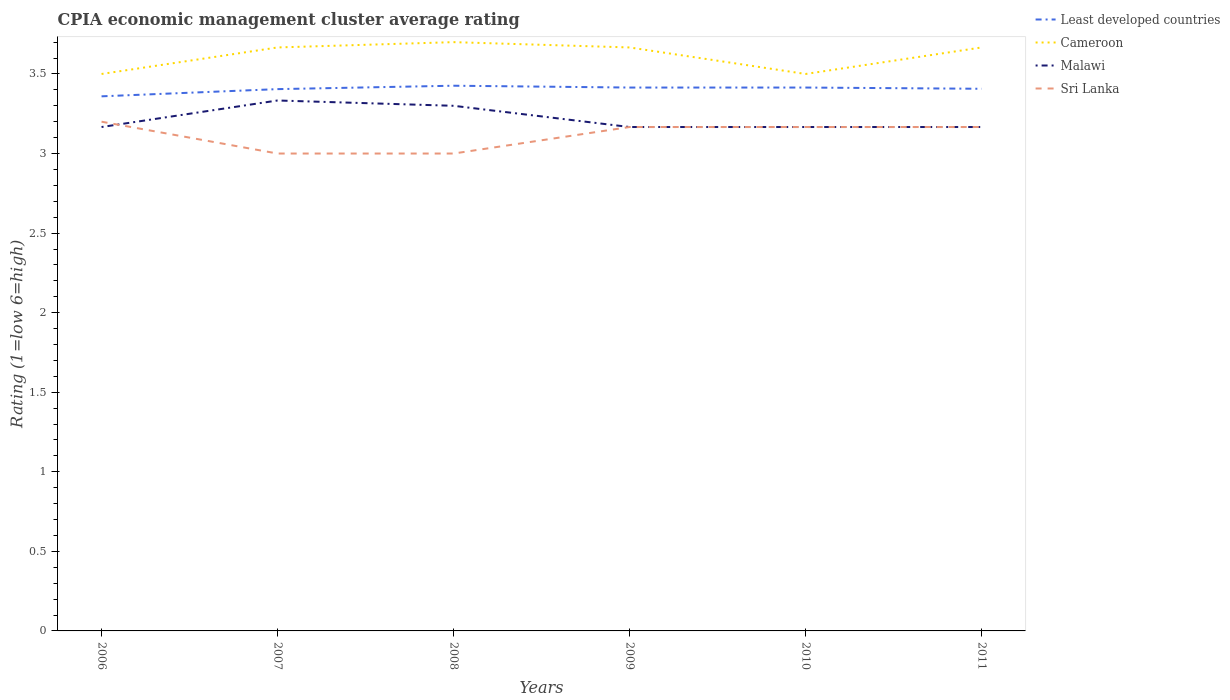How many different coloured lines are there?
Your answer should be very brief. 4. Does the line corresponding to Cameroon intersect with the line corresponding to Sri Lanka?
Make the answer very short. No. Across all years, what is the maximum CPIA rating in Sri Lanka?
Make the answer very short. 3. In which year was the CPIA rating in Malawi maximum?
Make the answer very short. 2006. What is the total CPIA rating in Sri Lanka in the graph?
Offer a terse response. -0.17. What is the difference between the highest and the second highest CPIA rating in Least developed countries?
Provide a succinct answer. 0.07. What is the difference between the highest and the lowest CPIA rating in Cameroon?
Keep it short and to the point. 4. Is the CPIA rating in Least developed countries strictly greater than the CPIA rating in Malawi over the years?
Your answer should be compact. No. How many lines are there?
Ensure brevity in your answer.  4. How many years are there in the graph?
Give a very brief answer. 6. What is the difference between two consecutive major ticks on the Y-axis?
Your response must be concise. 0.5. How many legend labels are there?
Provide a succinct answer. 4. How are the legend labels stacked?
Your response must be concise. Vertical. What is the title of the graph?
Ensure brevity in your answer.  CPIA economic management cluster average rating. What is the label or title of the X-axis?
Provide a succinct answer. Years. What is the label or title of the Y-axis?
Give a very brief answer. Rating (1=low 6=high). What is the Rating (1=low 6=high) of Least developed countries in 2006?
Your response must be concise. 3.36. What is the Rating (1=low 6=high) in Malawi in 2006?
Your answer should be very brief. 3.17. What is the Rating (1=low 6=high) in Sri Lanka in 2006?
Provide a short and direct response. 3.2. What is the Rating (1=low 6=high) of Least developed countries in 2007?
Your answer should be very brief. 3.4. What is the Rating (1=low 6=high) in Cameroon in 2007?
Offer a terse response. 3.67. What is the Rating (1=low 6=high) in Malawi in 2007?
Provide a succinct answer. 3.33. What is the Rating (1=low 6=high) in Sri Lanka in 2007?
Offer a very short reply. 3. What is the Rating (1=low 6=high) in Least developed countries in 2008?
Your response must be concise. 3.43. What is the Rating (1=low 6=high) in Malawi in 2008?
Ensure brevity in your answer.  3.3. What is the Rating (1=low 6=high) of Sri Lanka in 2008?
Your response must be concise. 3. What is the Rating (1=low 6=high) in Least developed countries in 2009?
Keep it short and to the point. 3.41. What is the Rating (1=low 6=high) in Cameroon in 2009?
Your answer should be compact. 3.67. What is the Rating (1=low 6=high) in Malawi in 2009?
Give a very brief answer. 3.17. What is the Rating (1=low 6=high) of Sri Lanka in 2009?
Ensure brevity in your answer.  3.17. What is the Rating (1=low 6=high) of Least developed countries in 2010?
Provide a succinct answer. 3.41. What is the Rating (1=low 6=high) of Cameroon in 2010?
Offer a terse response. 3.5. What is the Rating (1=low 6=high) of Malawi in 2010?
Offer a terse response. 3.17. What is the Rating (1=low 6=high) in Sri Lanka in 2010?
Make the answer very short. 3.17. What is the Rating (1=low 6=high) in Least developed countries in 2011?
Your response must be concise. 3.41. What is the Rating (1=low 6=high) in Cameroon in 2011?
Offer a very short reply. 3.67. What is the Rating (1=low 6=high) of Malawi in 2011?
Offer a very short reply. 3.17. What is the Rating (1=low 6=high) of Sri Lanka in 2011?
Keep it short and to the point. 3.17. Across all years, what is the maximum Rating (1=low 6=high) in Least developed countries?
Your answer should be very brief. 3.43. Across all years, what is the maximum Rating (1=low 6=high) of Malawi?
Your response must be concise. 3.33. Across all years, what is the maximum Rating (1=low 6=high) in Sri Lanka?
Provide a short and direct response. 3.2. Across all years, what is the minimum Rating (1=low 6=high) of Least developed countries?
Offer a terse response. 3.36. Across all years, what is the minimum Rating (1=low 6=high) in Malawi?
Offer a very short reply. 3.17. Across all years, what is the minimum Rating (1=low 6=high) of Sri Lanka?
Your answer should be very brief. 3. What is the total Rating (1=low 6=high) of Least developed countries in the graph?
Make the answer very short. 20.43. What is the total Rating (1=low 6=high) in Cameroon in the graph?
Your answer should be very brief. 21.7. What is the total Rating (1=low 6=high) of Malawi in the graph?
Your answer should be compact. 19.3. What is the difference between the Rating (1=low 6=high) of Least developed countries in 2006 and that in 2007?
Your response must be concise. -0.05. What is the difference between the Rating (1=low 6=high) of Sri Lanka in 2006 and that in 2007?
Offer a very short reply. 0.2. What is the difference between the Rating (1=low 6=high) of Least developed countries in 2006 and that in 2008?
Keep it short and to the point. -0.07. What is the difference between the Rating (1=low 6=high) in Malawi in 2006 and that in 2008?
Ensure brevity in your answer.  -0.13. What is the difference between the Rating (1=low 6=high) in Least developed countries in 2006 and that in 2009?
Make the answer very short. -0.06. What is the difference between the Rating (1=low 6=high) of Cameroon in 2006 and that in 2009?
Your response must be concise. -0.17. What is the difference between the Rating (1=low 6=high) in Malawi in 2006 and that in 2009?
Keep it short and to the point. 0. What is the difference between the Rating (1=low 6=high) of Least developed countries in 2006 and that in 2010?
Offer a terse response. -0.06. What is the difference between the Rating (1=low 6=high) in Cameroon in 2006 and that in 2010?
Make the answer very short. 0. What is the difference between the Rating (1=low 6=high) in Malawi in 2006 and that in 2010?
Offer a very short reply. 0. What is the difference between the Rating (1=low 6=high) of Least developed countries in 2006 and that in 2011?
Your response must be concise. -0.05. What is the difference between the Rating (1=low 6=high) of Malawi in 2006 and that in 2011?
Keep it short and to the point. 0. What is the difference between the Rating (1=low 6=high) of Least developed countries in 2007 and that in 2008?
Provide a short and direct response. -0.02. What is the difference between the Rating (1=low 6=high) in Cameroon in 2007 and that in 2008?
Provide a short and direct response. -0.03. What is the difference between the Rating (1=low 6=high) in Malawi in 2007 and that in 2008?
Give a very brief answer. 0.03. What is the difference between the Rating (1=low 6=high) in Sri Lanka in 2007 and that in 2008?
Offer a terse response. 0. What is the difference between the Rating (1=low 6=high) of Least developed countries in 2007 and that in 2009?
Give a very brief answer. -0.01. What is the difference between the Rating (1=low 6=high) of Least developed countries in 2007 and that in 2010?
Provide a short and direct response. -0.01. What is the difference between the Rating (1=low 6=high) in Sri Lanka in 2007 and that in 2010?
Ensure brevity in your answer.  -0.17. What is the difference between the Rating (1=low 6=high) in Least developed countries in 2007 and that in 2011?
Ensure brevity in your answer.  -0. What is the difference between the Rating (1=low 6=high) of Cameroon in 2007 and that in 2011?
Make the answer very short. 0. What is the difference between the Rating (1=low 6=high) of Malawi in 2007 and that in 2011?
Your answer should be very brief. 0.17. What is the difference between the Rating (1=low 6=high) in Least developed countries in 2008 and that in 2009?
Offer a terse response. 0.01. What is the difference between the Rating (1=low 6=high) of Cameroon in 2008 and that in 2009?
Offer a very short reply. 0.03. What is the difference between the Rating (1=low 6=high) of Malawi in 2008 and that in 2009?
Provide a short and direct response. 0.13. What is the difference between the Rating (1=low 6=high) in Sri Lanka in 2008 and that in 2009?
Make the answer very short. -0.17. What is the difference between the Rating (1=low 6=high) of Least developed countries in 2008 and that in 2010?
Offer a very short reply. 0.01. What is the difference between the Rating (1=low 6=high) in Malawi in 2008 and that in 2010?
Provide a succinct answer. 0.13. What is the difference between the Rating (1=low 6=high) of Sri Lanka in 2008 and that in 2010?
Keep it short and to the point. -0.17. What is the difference between the Rating (1=low 6=high) of Least developed countries in 2008 and that in 2011?
Make the answer very short. 0.02. What is the difference between the Rating (1=low 6=high) in Malawi in 2008 and that in 2011?
Provide a succinct answer. 0.13. What is the difference between the Rating (1=low 6=high) in Sri Lanka in 2008 and that in 2011?
Give a very brief answer. -0.17. What is the difference between the Rating (1=low 6=high) in Least developed countries in 2009 and that in 2010?
Offer a terse response. 0. What is the difference between the Rating (1=low 6=high) in Least developed countries in 2009 and that in 2011?
Offer a very short reply. 0.01. What is the difference between the Rating (1=low 6=high) of Least developed countries in 2010 and that in 2011?
Keep it short and to the point. 0.01. What is the difference between the Rating (1=low 6=high) in Sri Lanka in 2010 and that in 2011?
Provide a short and direct response. 0. What is the difference between the Rating (1=low 6=high) in Least developed countries in 2006 and the Rating (1=low 6=high) in Cameroon in 2007?
Your response must be concise. -0.31. What is the difference between the Rating (1=low 6=high) in Least developed countries in 2006 and the Rating (1=low 6=high) in Malawi in 2007?
Give a very brief answer. 0.03. What is the difference between the Rating (1=low 6=high) of Least developed countries in 2006 and the Rating (1=low 6=high) of Sri Lanka in 2007?
Your answer should be compact. 0.36. What is the difference between the Rating (1=low 6=high) of Least developed countries in 2006 and the Rating (1=low 6=high) of Cameroon in 2008?
Your answer should be very brief. -0.34. What is the difference between the Rating (1=low 6=high) of Least developed countries in 2006 and the Rating (1=low 6=high) of Malawi in 2008?
Provide a succinct answer. 0.06. What is the difference between the Rating (1=low 6=high) in Least developed countries in 2006 and the Rating (1=low 6=high) in Sri Lanka in 2008?
Ensure brevity in your answer.  0.36. What is the difference between the Rating (1=low 6=high) of Cameroon in 2006 and the Rating (1=low 6=high) of Malawi in 2008?
Your answer should be compact. 0.2. What is the difference between the Rating (1=low 6=high) in Cameroon in 2006 and the Rating (1=low 6=high) in Sri Lanka in 2008?
Your answer should be compact. 0.5. What is the difference between the Rating (1=low 6=high) of Malawi in 2006 and the Rating (1=low 6=high) of Sri Lanka in 2008?
Keep it short and to the point. 0.17. What is the difference between the Rating (1=low 6=high) in Least developed countries in 2006 and the Rating (1=low 6=high) in Cameroon in 2009?
Give a very brief answer. -0.31. What is the difference between the Rating (1=low 6=high) of Least developed countries in 2006 and the Rating (1=low 6=high) of Malawi in 2009?
Provide a short and direct response. 0.19. What is the difference between the Rating (1=low 6=high) in Least developed countries in 2006 and the Rating (1=low 6=high) in Sri Lanka in 2009?
Ensure brevity in your answer.  0.19. What is the difference between the Rating (1=low 6=high) in Cameroon in 2006 and the Rating (1=low 6=high) in Sri Lanka in 2009?
Offer a terse response. 0.33. What is the difference between the Rating (1=low 6=high) of Least developed countries in 2006 and the Rating (1=low 6=high) of Cameroon in 2010?
Provide a short and direct response. -0.14. What is the difference between the Rating (1=low 6=high) of Least developed countries in 2006 and the Rating (1=low 6=high) of Malawi in 2010?
Make the answer very short. 0.19. What is the difference between the Rating (1=low 6=high) of Least developed countries in 2006 and the Rating (1=low 6=high) of Sri Lanka in 2010?
Offer a very short reply. 0.19. What is the difference between the Rating (1=low 6=high) in Least developed countries in 2006 and the Rating (1=low 6=high) in Cameroon in 2011?
Ensure brevity in your answer.  -0.31. What is the difference between the Rating (1=low 6=high) in Least developed countries in 2006 and the Rating (1=low 6=high) in Malawi in 2011?
Provide a short and direct response. 0.19. What is the difference between the Rating (1=low 6=high) in Least developed countries in 2006 and the Rating (1=low 6=high) in Sri Lanka in 2011?
Your response must be concise. 0.19. What is the difference between the Rating (1=low 6=high) in Cameroon in 2006 and the Rating (1=low 6=high) in Sri Lanka in 2011?
Provide a succinct answer. 0.33. What is the difference between the Rating (1=low 6=high) of Malawi in 2006 and the Rating (1=low 6=high) of Sri Lanka in 2011?
Give a very brief answer. 0. What is the difference between the Rating (1=low 6=high) of Least developed countries in 2007 and the Rating (1=low 6=high) of Cameroon in 2008?
Offer a very short reply. -0.3. What is the difference between the Rating (1=low 6=high) in Least developed countries in 2007 and the Rating (1=low 6=high) in Malawi in 2008?
Make the answer very short. 0.1. What is the difference between the Rating (1=low 6=high) of Least developed countries in 2007 and the Rating (1=low 6=high) of Sri Lanka in 2008?
Make the answer very short. 0.4. What is the difference between the Rating (1=low 6=high) of Cameroon in 2007 and the Rating (1=low 6=high) of Malawi in 2008?
Give a very brief answer. 0.37. What is the difference between the Rating (1=low 6=high) of Cameroon in 2007 and the Rating (1=low 6=high) of Sri Lanka in 2008?
Provide a short and direct response. 0.67. What is the difference between the Rating (1=low 6=high) in Malawi in 2007 and the Rating (1=low 6=high) in Sri Lanka in 2008?
Your response must be concise. 0.33. What is the difference between the Rating (1=low 6=high) of Least developed countries in 2007 and the Rating (1=low 6=high) of Cameroon in 2009?
Offer a terse response. -0.26. What is the difference between the Rating (1=low 6=high) of Least developed countries in 2007 and the Rating (1=low 6=high) of Malawi in 2009?
Make the answer very short. 0.24. What is the difference between the Rating (1=low 6=high) in Least developed countries in 2007 and the Rating (1=low 6=high) in Sri Lanka in 2009?
Ensure brevity in your answer.  0.24. What is the difference between the Rating (1=low 6=high) in Cameroon in 2007 and the Rating (1=low 6=high) in Malawi in 2009?
Your response must be concise. 0.5. What is the difference between the Rating (1=low 6=high) in Least developed countries in 2007 and the Rating (1=low 6=high) in Cameroon in 2010?
Give a very brief answer. -0.1. What is the difference between the Rating (1=low 6=high) of Least developed countries in 2007 and the Rating (1=low 6=high) of Malawi in 2010?
Ensure brevity in your answer.  0.24. What is the difference between the Rating (1=low 6=high) of Least developed countries in 2007 and the Rating (1=low 6=high) of Sri Lanka in 2010?
Ensure brevity in your answer.  0.24. What is the difference between the Rating (1=low 6=high) in Cameroon in 2007 and the Rating (1=low 6=high) in Malawi in 2010?
Keep it short and to the point. 0.5. What is the difference between the Rating (1=low 6=high) of Malawi in 2007 and the Rating (1=low 6=high) of Sri Lanka in 2010?
Provide a short and direct response. 0.17. What is the difference between the Rating (1=low 6=high) in Least developed countries in 2007 and the Rating (1=low 6=high) in Cameroon in 2011?
Provide a short and direct response. -0.26. What is the difference between the Rating (1=low 6=high) of Least developed countries in 2007 and the Rating (1=low 6=high) of Malawi in 2011?
Ensure brevity in your answer.  0.24. What is the difference between the Rating (1=low 6=high) of Least developed countries in 2007 and the Rating (1=low 6=high) of Sri Lanka in 2011?
Your response must be concise. 0.24. What is the difference between the Rating (1=low 6=high) in Cameroon in 2007 and the Rating (1=low 6=high) in Malawi in 2011?
Ensure brevity in your answer.  0.5. What is the difference between the Rating (1=low 6=high) of Malawi in 2007 and the Rating (1=low 6=high) of Sri Lanka in 2011?
Offer a terse response. 0.17. What is the difference between the Rating (1=low 6=high) of Least developed countries in 2008 and the Rating (1=low 6=high) of Cameroon in 2009?
Ensure brevity in your answer.  -0.24. What is the difference between the Rating (1=low 6=high) of Least developed countries in 2008 and the Rating (1=low 6=high) of Malawi in 2009?
Your answer should be very brief. 0.26. What is the difference between the Rating (1=low 6=high) of Least developed countries in 2008 and the Rating (1=low 6=high) of Sri Lanka in 2009?
Make the answer very short. 0.26. What is the difference between the Rating (1=low 6=high) in Cameroon in 2008 and the Rating (1=low 6=high) in Malawi in 2009?
Keep it short and to the point. 0.53. What is the difference between the Rating (1=low 6=high) of Cameroon in 2008 and the Rating (1=low 6=high) of Sri Lanka in 2009?
Your answer should be very brief. 0.53. What is the difference between the Rating (1=low 6=high) in Malawi in 2008 and the Rating (1=low 6=high) in Sri Lanka in 2009?
Provide a succinct answer. 0.13. What is the difference between the Rating (1=low 6=high) in Least developed countries in 2008 and the Rating (1=low 6=high) in Cameroon in 2010?
Your answer should be compact. -0.07. What is the difference between the Rating (1=low 6=high) of Least developed countries in 2008 and the Rating (1=low 6=high) of Malawi in 2010?
Provide a succinct answer. 0.26. What is the difference between the Rating (1=low 6=high) in Least developed countries in 2008 and the Rating (1=low 6=high) in Sri Lanka in 2010?
Your response must be concise. 0.26. What is the difference between the Rating (1=low 6=high) in Cameroon in 2008 and the Rating (1=low 6=high) in Malawi in 2010?
Provide a short and direct response. 0.53. What is the difference between the Rating (1=low 6=high) in Cameroon in 2008 and the Rating (1=low 6=high) in Sri Lanka in 2010?
Your answer should be compact. 0.53. What is the difference between the Rating (1=low 6=high) in Malawi in 2008 and the Rating (1=low 6=high) in Sri Lanka in 2010?
Your answer should be compact. 0.13. What is the difference between the Rating (1=low 6=high) in Least developed countries in 2008 and the Rating (1=low 6=high) in Cameroon in 2011?
Provide a short and direct response. -0.24. What is the difference between the Rating (1=low 6=high) of Least developed countries in 2008 and the Rating (1=low 6=high) of Malawi in 2011?
Offer a terse response. 0.26. What is the difference between the Rating (1=low 6=high) in Least developed countries in 2008 and the Rating (1=low 6=high) in Sri Lanka in 2011?
Your answer should be compact. 0.26. What is the difference between the Rating (1=low 6=high) in Cameroon in 2008 and the Rating (1=low 6=high) in Malawi in 2011?
Make the answer very short. 0.53. What is the difference between the Rating (1=low 6=high) in Cameroon in 2008 and the Rating (1=low 6=high) in Sri Lanka in 2011?
Ensure brevity in your answer.  0.53. What is the difference between the Rating (1=low 6=high) of Malawi in 2008 and the Rating (1=low 6=high) of Sri Lanka in 2011?
Offer a terse response. 0.13. What is the difference between the Rating (1=low 6=high) in Least developed countries in 2009 and the Rating (1=low 6=high) in Cameroon in 2010?
Make the answer very short. -0.09. What is the difference between the Rating (1=low 6=high) in Least developed countries in 2009 and the Rating (1=low 6=high) in Malawi in 2010?
Give a very brief answer. 0.25. What is the difference between the Rating (1=low 6=high) in Least developed countries in 2009 and the Rating (1=low 6=high) in Sri Lanka in 2010?
Give a very brief answer. 0.25. What is the difference between the Rating (1=low 6=high) of Malawi in 2009 and the Rating (1=low 6=high) of Sri Lanka in 2010?
Your response must be concise. 0. What is the difference between the Rating (1=low 6=high) in Least developed countries in 2009 and the Rating (1=low 6=high) in Cameroon in 2011?
Provide a short and direct response. -0.25. What is the difference between the Rating (1=low 6=high) in Least developed countries in 2009 and the Rating (1=low 6=high) in Malawi in 2011?
Offer a terse response. 0.25. What is the difference between the Rating (1=low 6=high) of Least developed countries in 2009 and the Rating (1=low 6=high) of Sri Lanka in 2011?
Your response must be concise. 0.25. What is the difference between the Rating (1=low 6=high) in Least developed countries in 2010 and the Rating (1=low 6=high) in Cameroon in 2011?
Offer a terse response. -0.25. What is the difference between the Rating (1=low 6=high) of Least developed countries in 2010 and the Rating (1=low 6=high) of Malawi in 2011?
Offer a terse response. 0.25. What is the difference between the Rating (1=low 6=high) of Least developed countries in 2010 and the Rating (1=low 6=high) of Sri Lanka in 2011?
Keep it short and to the point. 0.25. What is the difference between the Rating (1=low 6=high) of Cameroon in 2010 and the Rating (1=low 6=high) of Sri Lanka in 2011?
Give a very brief answer. 0.33. What is the difference between the Rating (1=low 6=high) of Malawi in 2010 and the Rating (1=low 6=high) of Sri Lanka in 2011?
Provide a short and direct response. 0. What is the average Rating (1=low 6=high) in Least developed countries per year?
Offer a terse response. 3.4. What is the average Rating (1=low 6=high) in Cameroon per year?
Offer a very short reply. 3.62. What is the average Rating (1=low 6=high) in Malawi per year?
Provide a succinct answer. 3.22. What is the average Rating (1=low 6=high) in Sri Lanka per year?
Ensure brevity in your answer.  3.12. In the year 2006, what is the difference between the Rating (1=low 6=high) of Least developed countries and Rating (1=low 6=high) of Cameroon?
Provide a short and direct response. -0.14. In the year 2006, what is the difference between the Rating (1=low 6=high) of Least developed countries and Rating (1=low 6=high) of Malawi?
Your answer should be compact. 0.19. In the year 2006, what is the difference between the Rating (1=low 6=high) in Least developed countries and Rating (1=low 6=high) in Sri Lanka?
Ensure brevity in your answer.  0.16. In the year 2006, what is the difference between the Rating (1=low 6=high) of Cameroon and Rating (1=low 6=high) of Malawi?
Provide a succinct answer. 0.33. In the year 2006, what is the difference between the Rating (1=low 6=high) of Malawi and Rating (1=low 6=high) of Sri Lanka?
Your answer should be compact. -0.03. In the year 2007, what is the difference between the Rating (1=low 6=high) in Least developed countries and Rating (1=low 6=high) in Cameroon?
Your response must be concise. -0.26. In the year 2007, what is the difference between the Rating (1=low 6=high) of Least developed countries and Rating (1=low 6=high) of Malawi?
Keep it short and to the point. 0.07. In the year 2007, what is the difference between the Rating (1=low 6=high) of Least developed countries and Rating (1=low 6=high) of Sri Lanka?
Ensure brevity in your answer.  0.4. In the year 2007, what is the difference between the Rating (1=low 6=high) in Malawi and Rating (1=low 6=high) in Sri Lanka?
Make the answer very short. 0.33. In the year 2008, what is the difference between the Rating (1=low 6=high) of Least developed countries and Rating (1=low 6=high) of Cameroon?
Ensure brevity in your answer.  -0.27. In the year 2008, what is the difference between the Rating (1=low 6=high) in Least developed countries and Rating (1=low 6=high) in Malawi?
Give a very brief answer. 0.13. In the year 2008, what is the difference between the Rating (1=low 6=high) in Least developed countries and Rating (1=low 6=high) in Sri Lanka?
Give a very brief answer. 0.43. In the year 2008, what is the difference between the Rating (1=low 6=high) in Cameroon and Rating (1=low 6=high) in Sri Lanka?
Your answer should be very brief. 0.7. In the year 2008, what is the difference between the Rating (1=low 6=high) in Malawi and Rating (1=low 6=high) in Sri Lanka?
Offer a terse response. 0.3. In the year 2009, what is the difference between the Rating (1=low 6=high) in Least developed countries and Rating (1=low 6=high) in Cameroon?
Offer a terse response. -0.25. In the year 2009, what is the difference between the Rating (1=low 6=high) in Least developed countries and Rating (1=low 6=high) in Malawi?
Your answer should be compact. 0.25. In the year 2009, what is the difference between the Rating (1=low 6=high) in Least developed countries and Rating (1=low 6=high) in Sri Lanka?
Give a very brief answer. 0.25. In the year 2009, what is the difference between the Rating (1=low 6=high) in Cameroon and Rating (1=low 6=high) in Sri Lanka?
Make the answer very short. 0.5. In the year 2010, what is the difference between the Rating (1=low 6=high) in Least developed countries and Rating (1=low 6=high) in Cameroon?
Provide a succinct answer. -0.09. In the year 2010, what is the difference between the Rating (1=low 6=high) in Least developed countries and Rating (1=low 6=high) in Malawi?
Keep it short and to the point. 0.25. In the year 2010, what is the difference between the Rating (1=low 6=high) in Least developed countries and Rating (1=low 6=high) in Sri Lanka?
Give a very brief answer. 0.25. In the year 2010, what is the difference between the Rating (1=low 6=high) of Cameroon and Rating (1=low 6=high) of Sri Lanka?
Provide a succinct answer. 0.33. In the year 2011, what is the difference between the Rating (1=low 6=high) of Least developed countries and Rating (1=low 6=high) of Cameroon?
Your answer should be very brief. -0.26. In the year 2011, what is the difference between the Rating (1=low 6=high) of Least developed countries and Rating (1=low 6=high) of Malawi?
Offer a very short reply. 0.24. In the year 2011, what is the difference between the Rating (1=low 6=high) in Least developed countries and Rating (1=low 6=high) in Sri Lanka?
Provide a short and direct response. 0.24. In the year 2011, what is the difference between the Rating (1=low 6=high) of Cameroon and Rating (1=low 6=high) of Malawi?
Ensure brevity in your answer.  0.5. In the year 2011, what is the difference between the Rating (1=low 6=high) of Cameroon and Rating (1=low 6=high) of Sri Lanka?
Your answer should be compact. 0.5. In the year 2011, what is the difference between the Rating (1=low 6=high) in Malawi and Rating (1=low 6=high) in Sri Lanka?
Offer a very short reply. 0. What is the ratio of the Rating (1=low 6=high) of Least developed countries in 2006 to that in 2007?
Your response must be concise. 0.99. What is the ratio of the Rating (1=low 6=high) of Cameroon in 2006 to that in 2007?
Your answer should be compact. 0.95. What is the ratio of the Rating (1=low 6=high) of Malawi in 2006 to that in 2007?
Ensure brevity in your answer.  0.95. What is the ratio of the Rating (1=low 6=high) of Sri Lanka in 2006 to that in 2007?
Offer a very short reply. 1.07. What is the ratio of the Rating (1=low 6=high) of Least developed countries in 2006 to that in 2008?
Give a very brief answer. 0.98. What is the ratio of the Rating (1=low 6=high) in Cameroon in 2006 to that in 2008?
Keep it short and to the point. 0.95. What is the ratio of the Rating (1=low 6=high) of Malawi in 2006 to that in 2008?
Your response must be concise. 0.96. What is the ratio of the Rating (1=low 6=high) of Sri Lanka in 2006 to that in 2008?
Offer a very short reply. 1.07. What is the ratio of the Rating (1=low 6=high) in Least developed countries in 2006 to that in 2009?
Your answer should be compact. 0.98. What is the ratio of the Rating (1=low 6=high) in Cameroon in 2006 to that in 2009?
Provide a succinct answer. 0.95. What is the ratio of the Rating (1=low 6=high) of Sri Lanka in 2006 to that in 2009?
Ensure brevity in your answer.  1.01. What is the ratio of the Rating (1=low 6=high) of Least developed countries in 2006 to that in 2010?
Your answer should be compact. 0.98. What is the ratio of the Rating (1=low 6=high) in Cameroon in 2006 to that in 2010?
Your answer should be very brief. 1. What is the ratio of the Rating (1=low 6=high) in Malawi in 2006 to that in 2010?
Provide a succinct answer. 1. What is the ratio of the Rating (1=low 6=high) of Sri Lanka in 2006 to that in 2010?
Your answer should be very brief. 1.01. What is the ratio of the Rating (1=low 6=high) in Least developed countries in 2006 to that in 2011?
Provide a succinct answer. 0.99. What is the ratio of the Rating (1=low 6=high) in Cameroon in 2006 to that in 2011?
Provide a short and direct response. 0.95. What is the ratio of the Rating (1=low 6=high) of Malawi in 2006 to that in 2011?
Ensure brevity in your answer.  1. What is the ratio of the Rating (1=low 6=high) in Sri Lanka in 2006 to that in 2011?
Ensure brevity in your answer.  1.01. What is the ratio of the Rating (1=low 6=high) in Least developed countries in 2007 to that in 2008?
Your response must be concise. 0.99. What is the ratio of the Rating (1=low 6=high) of Cameroon in 2007 to that in 2008?
Keep it short and to the point. 0.99. What is the ratio of the Rating (1=low 6=high) of Malawi in 2007 to that in 2008?
Your answer should be very brief. 1.01. What is the ratio of the Rating (1=low 6=high) of Sri Lanka in 2007 to that in 2008?
Make the answer very short. 1. What is the ratio of the Rating (1=low 6=high) of Malawi in 2007 to that in 2009?
Keep it short and to the point. 1.05. What is the ratio of the Rating (1=low 6=high) in Sri Lanka in 2007 to that in 2009?
Ensure brevity in your answer.  0.95. What is the ratio of the Rating (1=low 6=high) of Cameroon in 2007 to that in 2010?
Your response must be concise. 1.05. What is the ratio of the Rating (1=low 6=high) in Malawi in 2007 to that in 2010?
Make the answer very short. 1.05. What is the ratio of the Rating (1=low 6=high) in Malawi in 2007 to that in 2011?
Provide a short and direct response. 1.05. What is the ratio of the Rating (1=low 6=high) of Sri Lanka in 2007 to that in 2011?
Offer a very short reply. 0.95. What is the ratio of the Rating (1=low 6=high) of Cameroon in 2008 to that in 2009?
Give a very brief answer. 1.01. What is the ratio of the Rating (1=low 6=high) of Malawi in 2008 to that in 2009?
Provide a succinct answer. 1.04. What is the ratio of the Rating (1=low 6=high) in Least developed countries in 2008 to that in 2010?
Offer a terse response. 1. What is the ratio of the Rating (1=low 6=high) of Cameroon in 2008 to that in 2010?
Your response must be concise. 1.06. What is the ratio of the Rating (1=low 6=high) in Malawi in 2008 to that in 2010?
Ensure brevity in your answer.  1.04. What is the ratio of the Rating (1=low 6=high) of Least developed countries in 2008 to that in 2011?
Your answer should be compact. 1.01. What is the ratio of the Rating (1=low 6=high) of Cameroon in 2008 to that in 2011?
Ensure brevity in your answer.  1.01. What is the ratio of the Rating (1=low 6=high) in Malawi in 2008 to that in 2011?
Keep it short and to the point. 1.04. What is the ratio of the Rating (1=low 6=high) in Sri Lanka in 2008 to that in 2011?
Give a very brief answer. 0.95. What is the ratio of the Rating (1=low 6=high) in Least developed countries in 2009 to that in 2010?
Your answer should be compact. 1. What is the ratio of the Rating (1=low 6=high) in Cameroon in 2009 to that in 2010?
Your answer should be compact. 1.05. What is the ratio of the Rating (1=low 6=high) in Malawi in 2009 to that in 2010?
Ensure brevity in your answer.  1. What is the ratio of the Rating (1=low 6=high) of Cameroon in 2009 to that in 2011?
Give a very brief answer. 1. What is the ratio of the Rating (1=low 6=high) of Malawi in 2009 to that in 2011?
Your answer should be compact. 1. What is the ratio of the Rating (1=low 6=high) of Cameroon in 2010 to that in 2011?
Provide a succinct answer. 0.95. What is the ratio of the Rating (1=low 6=high) of Sri Lanka in 2010 to that in 2011?
Your answer should be very brief. 1. What is the difference between the highest and the second highest Rating (1=low 6=high) in Least developed countries?
Offer a terse response. 0.01. What is the difference between the highest and the second highest Rating (1=low 6=high) in Sri Lanka?
Ensure brevity in your answer.  0.03. What is the difference between the highest and the lowest Rating (1=low 6=high) in Least developed countries?
Offer a terse response. 0.07. What is the difference between the highest and the lowest Rating (1=low 6=high) of Sri Lanka?
Give a very brief answer. 0.2. 